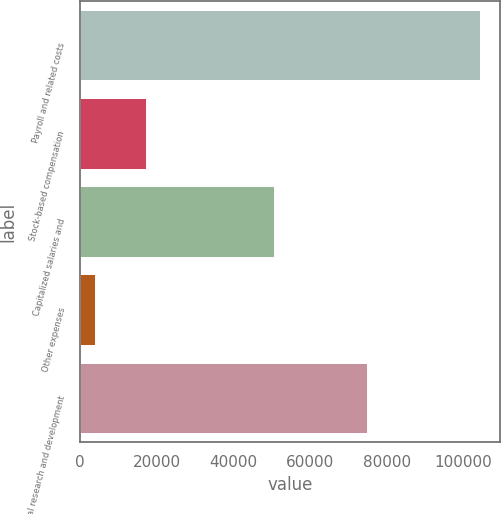<chart> <loc_0><loc_0><loc_500><loc_500><bar_chart><fcel>Payroll and related costs<fcel>Stock-based compensation<fcel>Capitalized salaries and<fcel>Other expenses<fcel>Total research and development<nl><fcel>104244<fcel>17275<fcel>50648<fcel>3873<fcel>74744<nl></chart> 